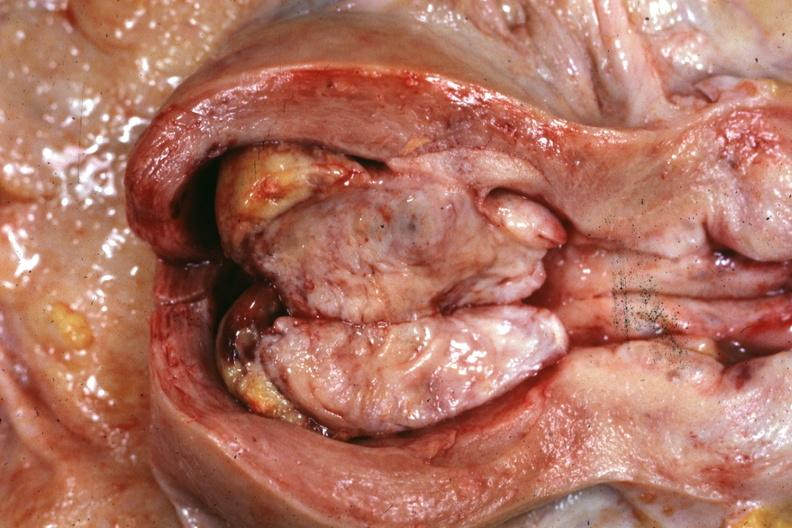what does this image show?
Answer the question using a single word or phrase. Opened uterus with polypoid mass 